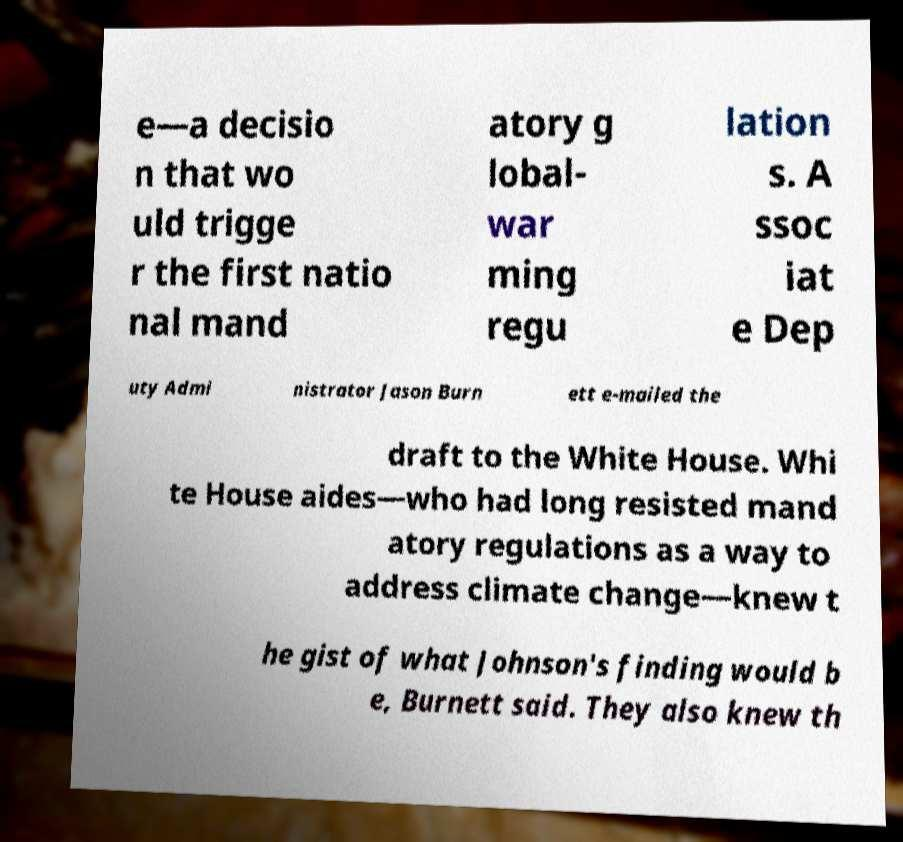Can you accurately transcribe the text from the provided image for me? e—a decisio n that wo uld trigge r the first natio nal mand atory g lobal- war ming regu lation s. A ssoc iat e Dep uty Admi nistrator Jason Burn ett e-mailed the draft to the White House. Whi te House aides—who had long resisted mand atory regulations as a way to address climate change—knew t he gist of what Johnson's finding would b e, Burnett said. They also knew th 